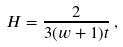<formula> <loc_0><loc_0><loc_500><loc_500>H = \frac { 2 } { 3 ( w + 1 ) t } \, ,</formula> 